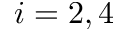<formula> <loc_0><loc_0><loc_500><loc_500>i = 2 , 4</formula> 